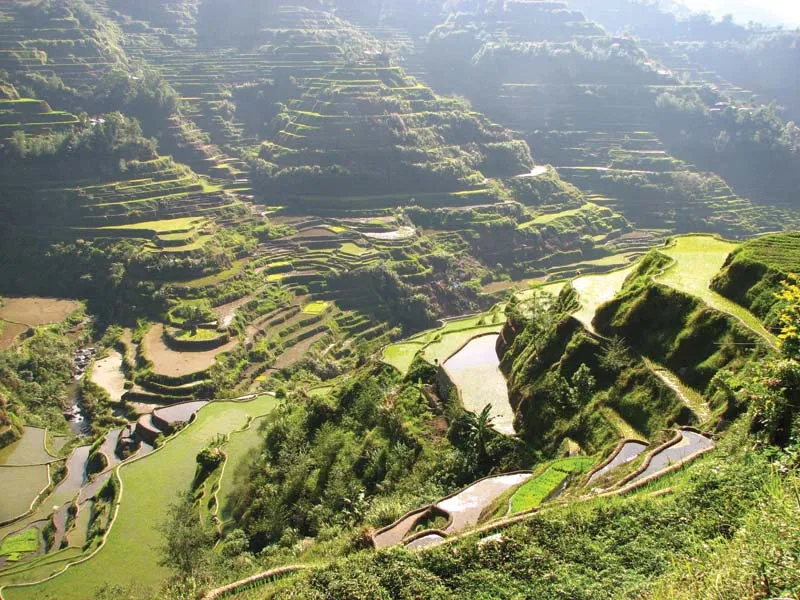What do you see happening in this image? The image showcases the stunning Banaue Rice Terraces, a UNESCO World Heritage Site in the Philippines. These terraces are expertly carved into the mountainside, their vibrant green hues indicating thriving crops. Viewed from a high vantage point, the terraces cascade down like a grand staircase. The bright sunlight highlights the terraces' intricate contours, while shadows add depth to the landscape. A small river winds through, providing essential water for the crops. Scattered buildings—likely homes or storage structures—punctuate the scene, emphasizing the terraces' vastness. This image celebrates the ingenuity and dedication of the Ifugao people who have skillfully maintained these terraces for generations. 